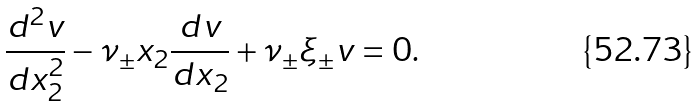Convert formula to latex. <formula><loc_0><loc_0><loc_500><loc_500>\frac { d ^ { 2 } v } { d x _ { 2 } ^ { 2 } } - \nu _ { \pm } x _ { 2 } \frac { d v } { d x _ { 2 } } + \nu _ { \pm } \xi _ { \pm } v = 0 .</formula> 